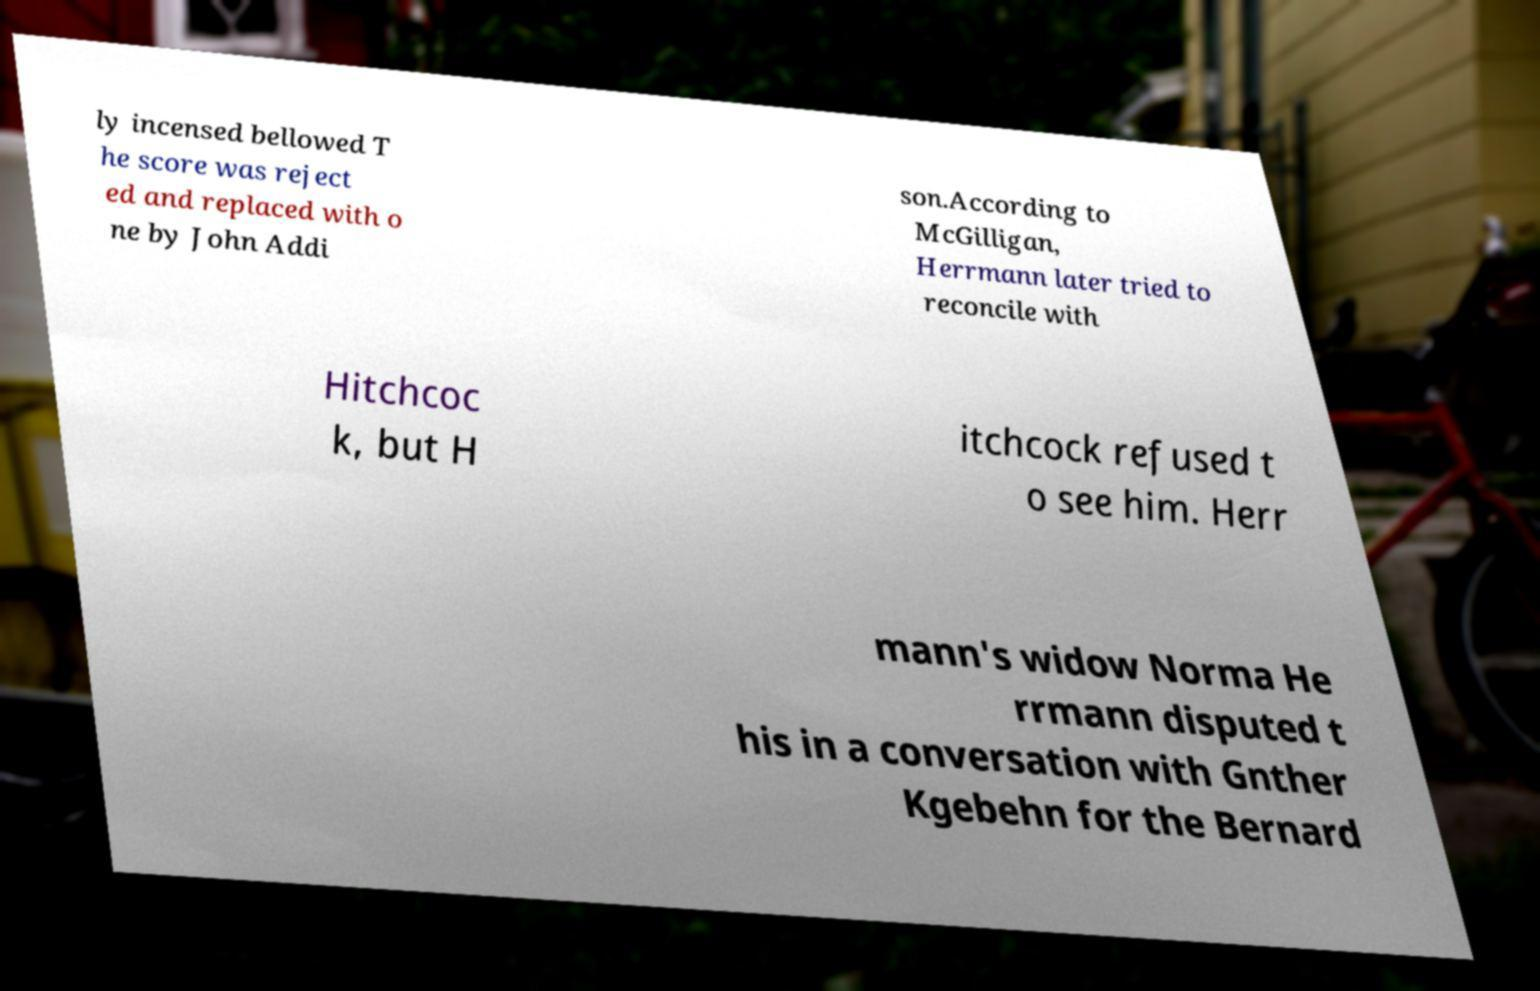Could you extract and type out the text from this image? ly incensed bellowed T he score was reject ed and replaced with o ne by John Addi son.According to McGilligan, Herrmann later tried to reconcile with Hitchcoc k, but H itchcock refused t o see him. Herr mann's widow Norma He rrmann disputed t his in a conversation with Gnther Kgebehn for the Bernard 